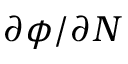<formula> <loc_0><loc_0><loc_500><loc_500>\partial \phi / \partial N</formula> 